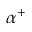<formula> <loc_0><loc_0><loc_500><loc_500>\alpha ^ { + }</formula> 